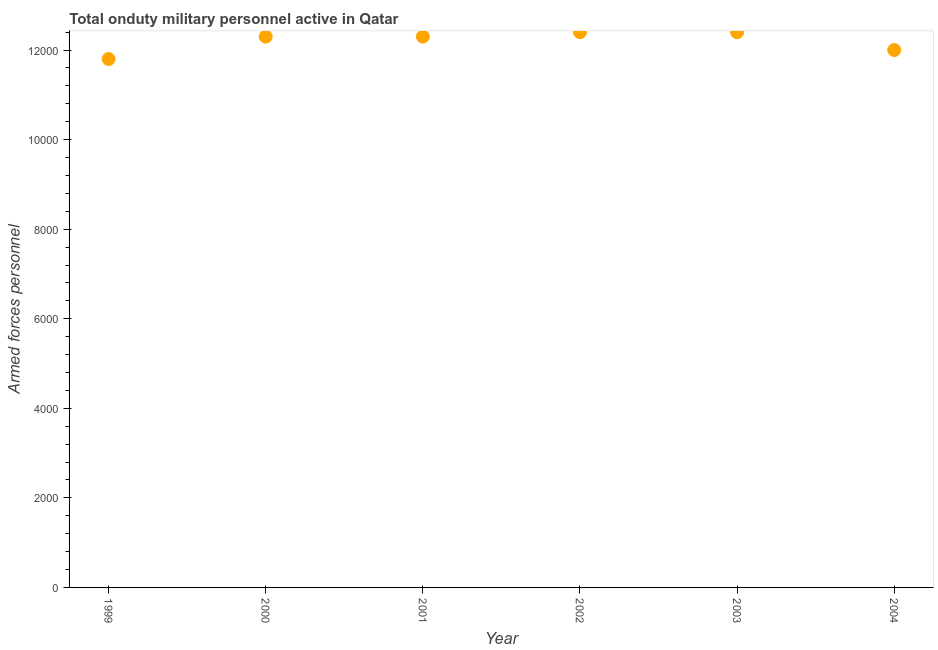What is the number of armed forces personnel in 2001?
Make the answer very short. 1.23e+04. Across all years, what is the maximum number of armed forces personnel?
Offer a very short reply. 1.24e+04. Across all years, what is the minimum number of armed forces personnel?
Your answer should be compact. 1.18e+04. What is the sum of the number of armed forces personnel?
Give a very brief answer. 7.32e+04. What is the average number of armed forces personnel per year?
Offer a terse response. 1.22e+04. What is the median number of armed forces personnel?
Your answer should be compact. 1.23e+04. Do a majority of the years between 2003 and 2000 (inclusive) have number of armed forces personnel greater than 800 ?
Your answer should be very brief. Yes. What is the ratio of the number of armed forces personnel in 2000 to that in 2003?
Ensure brevity in your answer.  0.99. Is the sum of the number of armed forces personnel in 1999 and 2004 greater than the maximum number of armed forces personnel across all years?
Your response must be concise. Yes. What is the difference between the highest and the lowest number of armed forces personnel?
Make the answer very short. 600. In how many years, is the number of armed forces personnel greater than the average number of armed forces personnel taken over all years?
Ensure brevity in your answer.  4. Does the number of armed forces personnel monotonically increase over the years?
Provide a short and direct response. No. How many years are there in the graph?
Your response must be concise. 6. Are the values on the major ticks of Y-axis written in scientific E-notation?
Give a very brief answer. No. What is the title of the graph?
Your response must be concise. Total onduty military personnel active in Qatar. What is the label or title of the X-axis?
Give a very brief answer. Year. What is the label or title of the Y-axis?
Keep it short and to the point. Armed forces personnel. What is the Armed forces personnel in 1999?
Offer a very short reply. 1.18e+04. What is the Armed forces personnel in 2000?
Your answer should be very brief. 1.23e+04. What is the Armed forces personnel in 2001?
Offer a very short reply. 1.23e+04. What is the Armed forces personnel in 2002?
Give a very brief answer. 1.24e+04. What is the Armed forces personnel in 2003?
Ensure brevity in your answer.  1.24e+04. What is the Armed forces personnel in 2004?
Offer a terse response. 1.20e+04. What is the difference between the Armed forces personnel in 1999 and 2000?
Your response must be concise. -500. What is the difference between the Armed forces personnel in 1999 and 2001?
Provide a short and direct response. -500. What is the difference between the Armed forces personnel in 1999 and 2002?
Offer a terse response. -600. What is the difference between the Armed forces personnel in 1999 and 2003?
Ensure brevity in your answer.  -600. What is the difference between the Armed forces personnel in 1999 and 2004?
Give a very brief answer. -200. What is the difference between the Armed forces personnel in 2000 and 2001?
Provide a succinct answer. 0. What is the difference between the Armed forces personnel in 2000 and 2002?
Your answer should be very brief. -100. What is the difference between the Armed forces personnel in 2000 and 2003?
Provide a succinct answer. -100. What is the difference between the Armed forces personnel in 2000 and 2004?
Your answer should be compact. 300. What is the difference between the Armed forces personnel in 2001 and 2002?
Offer a terse response. -100. What is the difference between the Armed forces personnel in 2001 and 2003?
Your answer should be very brief. -100. What is the difference between the Armed forces personnel in 2001 and 2004?
Provide a succinct answer. 300. What is the difference between the Armed forces personnel in 2002 and 2004?
Offer a very short reply. 400. What is the ratio of the Armed forces personnel in 1999 to that in 2000?
Ensure brevity in your answer.  0.96. What is the ratio of the Armed forces personnel in 1999 to that in 2003?
Offer a terse response. 0.95. What is the ratio of the Armed forces personnel in 2000 to that in 2001?
Make the answer very short. 1. What is the ratio of the Armed forces personnel in 2001 to that in 2002?
Keep it short and to the point. 0.99. What is the ratio of the Armed forces personnel in 2001 to that in 2004?
Your response must be concise. 1.02. What is the ratio of the Armed forces personnel in 2002 to that in 2003?
Give a very brief answer. 1. What is the ratio of the Armed forces personnel in 2002 to that in 2004?
Offer a very short reply. 1.03. What is the ratio of the Armed forces personnel in 2003 to that in 2004?
Offer a terse response. 1.03. 